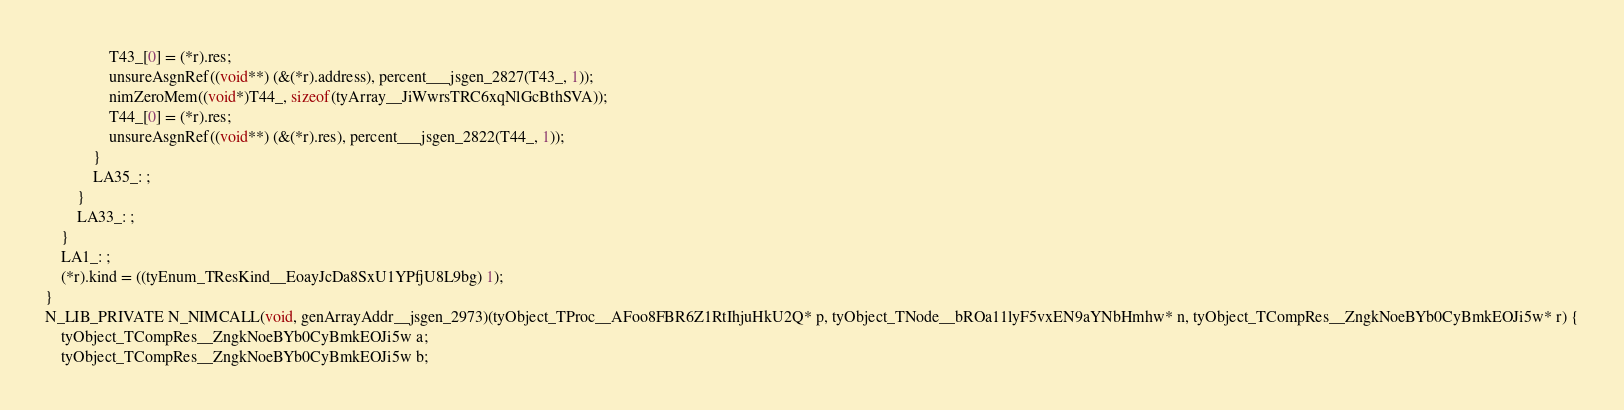Convert code to text. <code><loc_0><loc_0><loc_500><loc_500><_C_>				T43_[0] = (*r).res;
				unsureAsgnRef((void**) (&(*r).address), percent___jsgen_2827(T43_, 1));
				nimZeroMem((void*)T44_, sizeof(tyArray__JiWwrsTRC6xqNlGcBthSVA));
				T44_[0] = (*r).res;
				unsureAsgnRef((void**) (&(*r).res), percent___jsgen_2822(T44_, 1));
			}
			LA35_: ;
		}
		LA33_: ;
	}
	LA1_: ;
	(*r).kind = ((tyEnum_TResKind__EoayJcDa8SxU1YPfjU8L9bg) 1);
}
N_LIB_PRIVATE N_NIMCALL(void, genArrayAddr__jsgen_2973)(tyObject_TProc__AFoo8FBR6Z1RtIhjuHkU2Q* p, tyObject_TNode__bROa11lyF5vxEN9aYNbHmhw* n, tyObject_TCompRes__ZngkNoeBYb0CyBmkEOJi5w* r) {
	tyObject_TCompRes__ZngkNoeBYb0CyBmkEOJi5w a;
	tyObject_TCompRes__ZngkNoeBYb0CyBmkEOJi5w b;</code> 